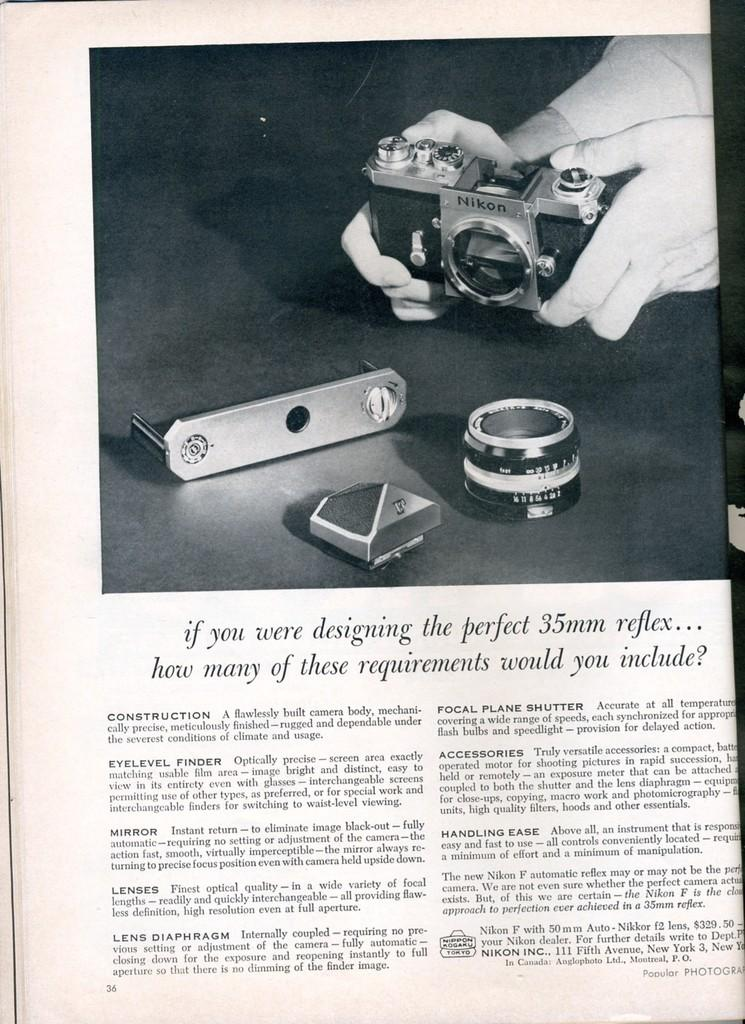What is the person in the image holding? The person in the image is holding a camera. Are there any additional items related to the camera in the image? Yes, there are camera accessories visible in the image. What can be found at the bottom of the image? There is some text at the bottom of the image. How many baby mice are crawling on the camera in the image? There are no baby mice present in the image; it features a person holding a camera with camera accessories. 